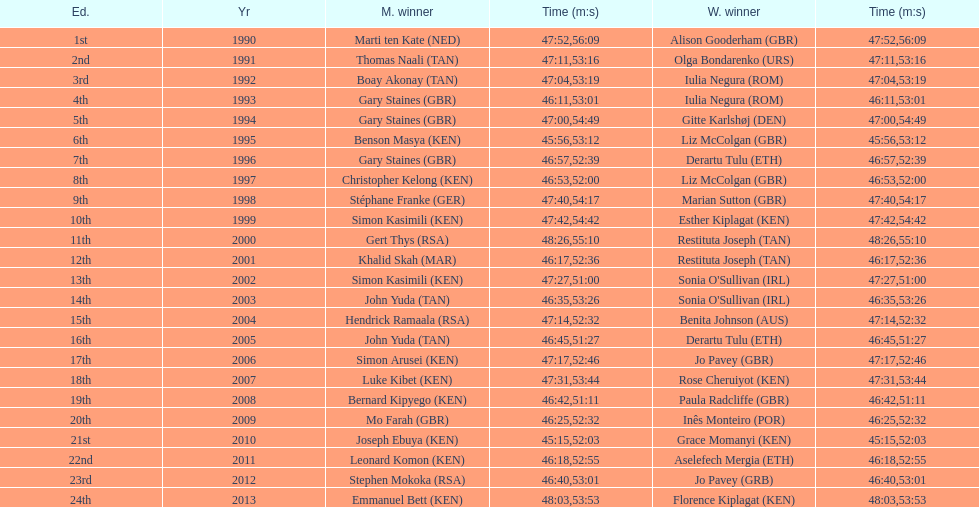Who has the fastest recorded finish for the men's bupa great south run, between 1990 and 2013? Joseph Ebuya (KEN). 